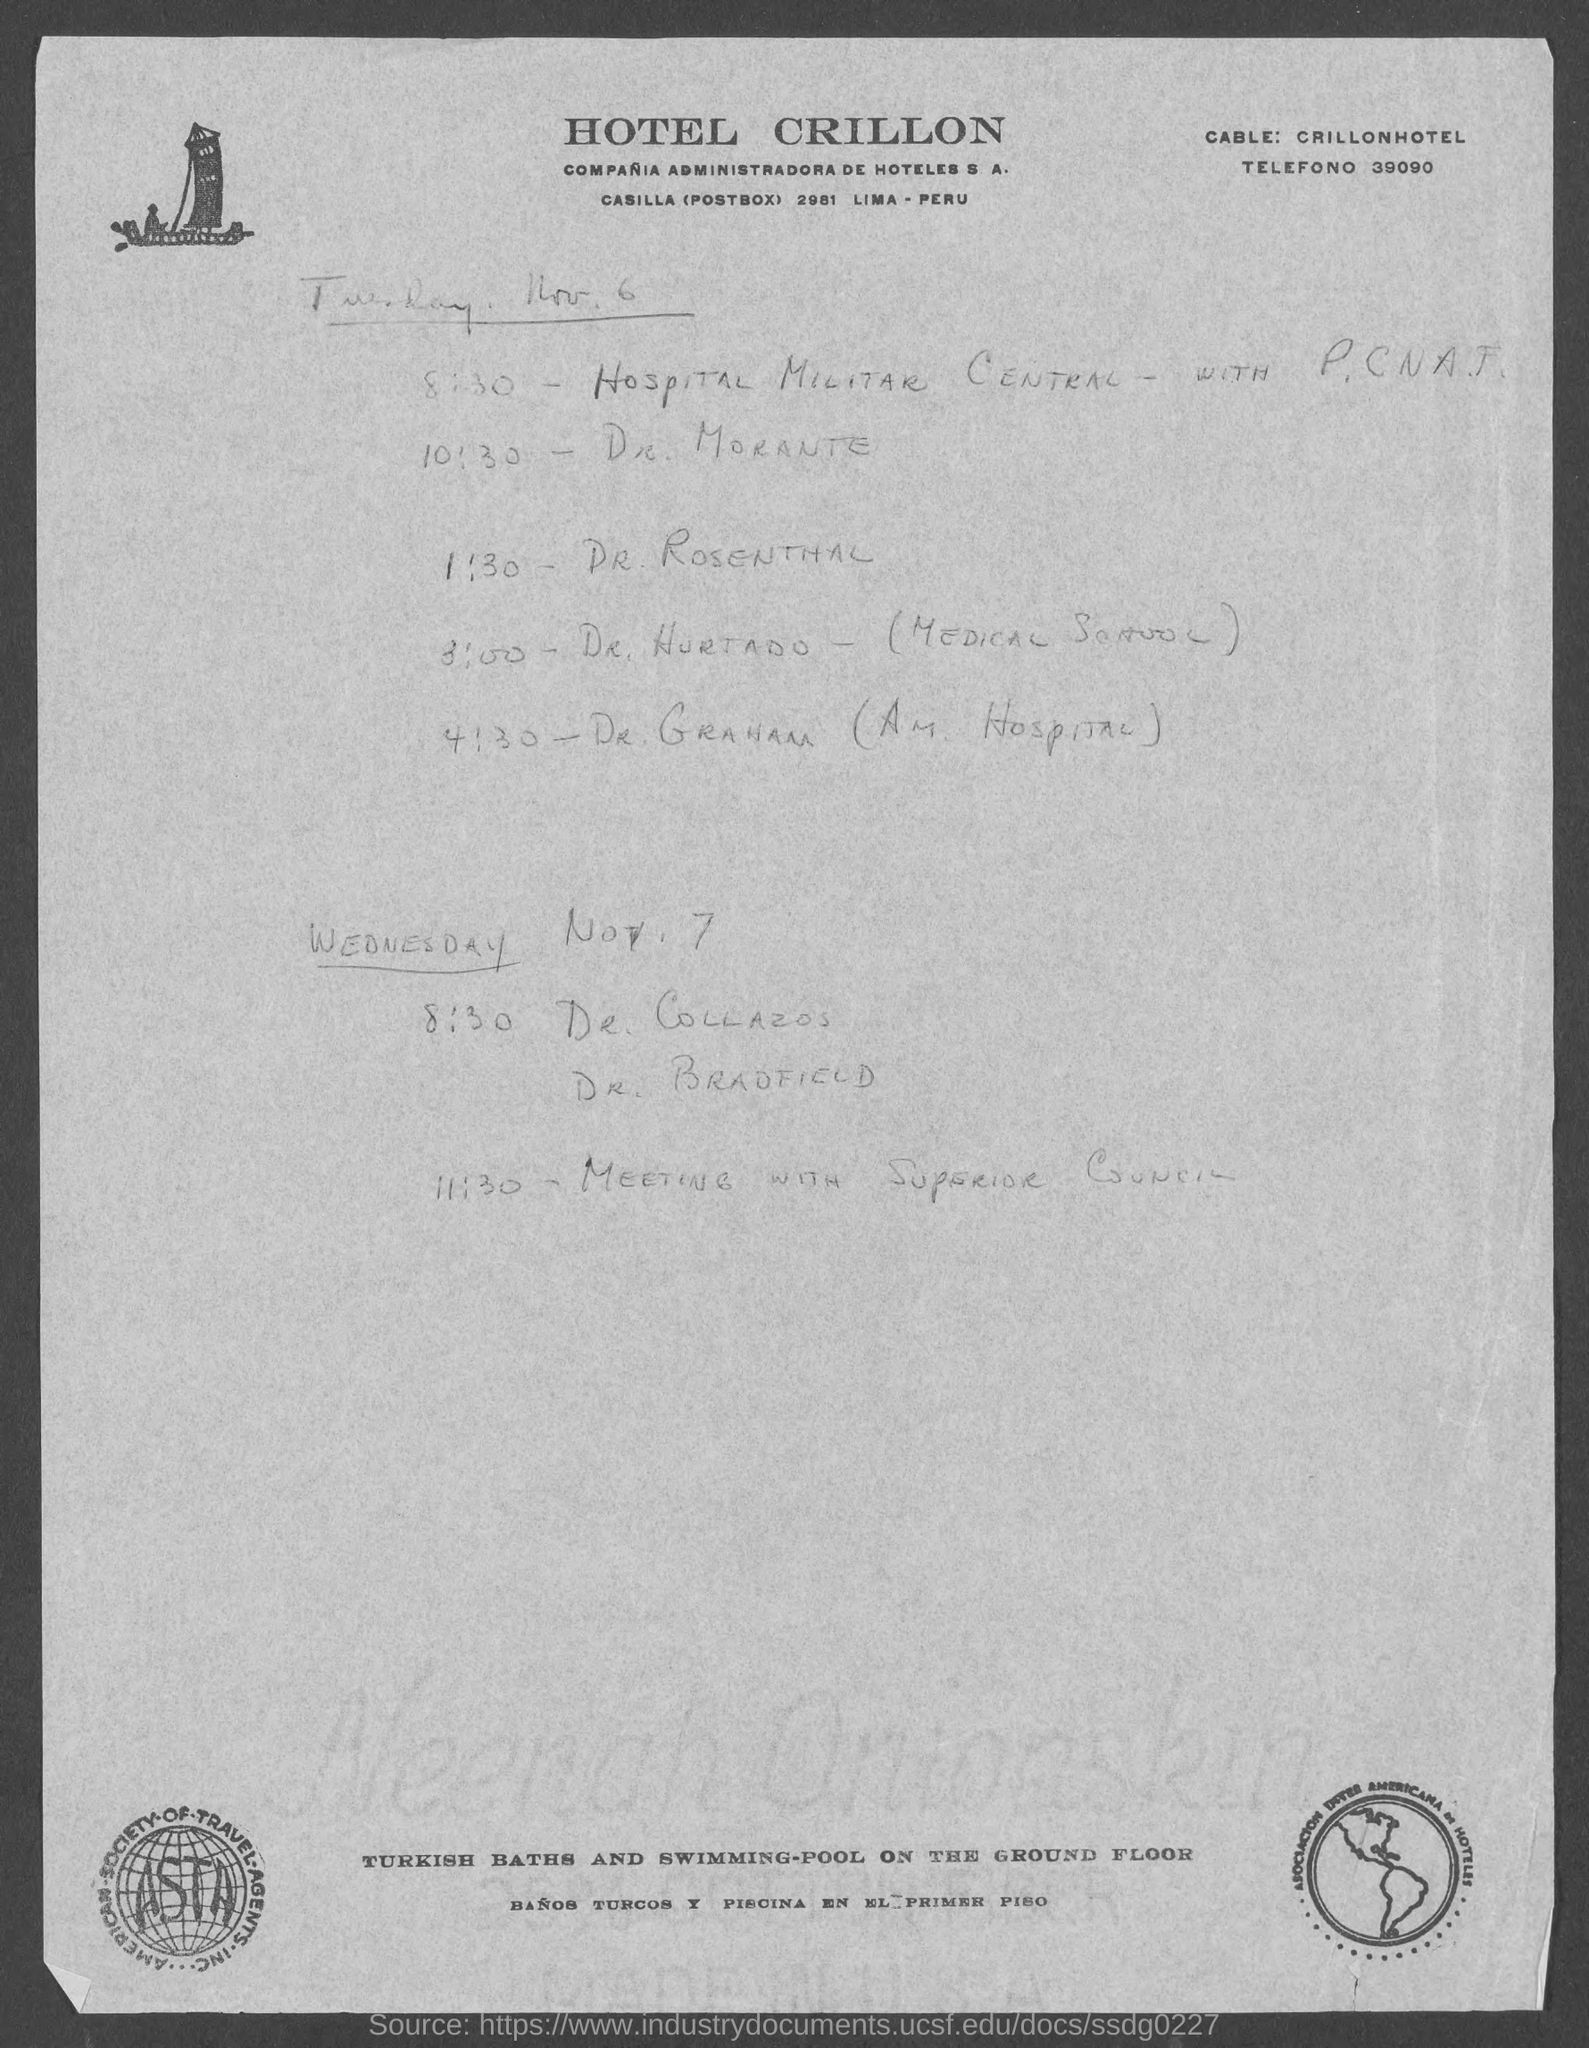Identify some key points in this picture. Please provide the TELEFONO number that is located at the top left corner of the page. The logo on the left bottom corner of the page features the text 'ASTA'. Provide "CABLE:" data, specifically "CRILLONHOTEL..," in the designated corner of the page. The POSTBOX number of HOTEL CRILLON is 2981. The name of the hotel at the top of the page is HOTEL CRILLON. 